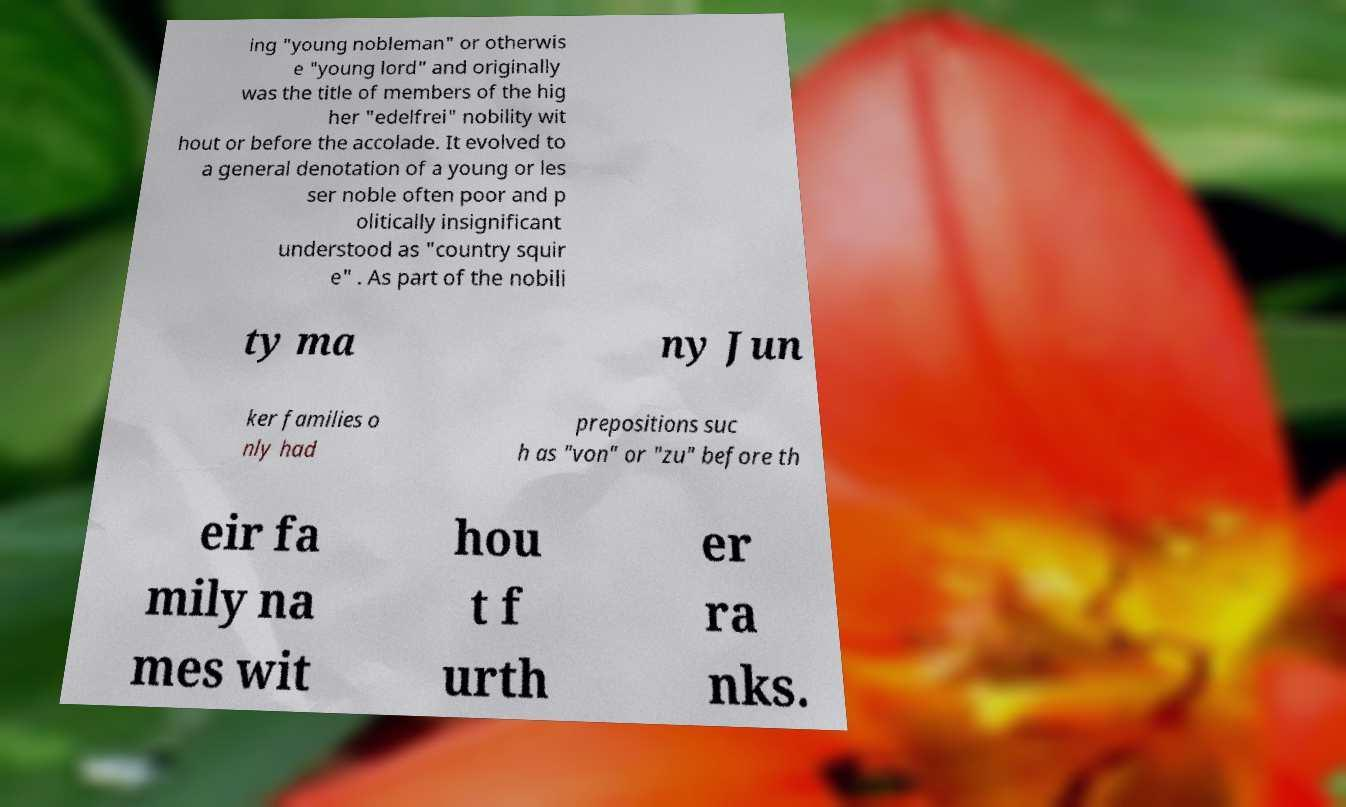For documentation purposes, I need the text within this image transcribed. Could you provide that? ing "young nobleman" or otherwis e "young lord" and originally was the title of members of the hig her "edelfrei" nobility wit hout or before the accolade. It evolved to a general denotation of a young or les ser noble often poor and p olitically insignificant understood as "country squir e" . As part of the nobili ty ma ny Jun ker families o nly had prepositions suc h as "von" or "zu" before th eir fa mily na mes wit hou t f urth er ra nks. 